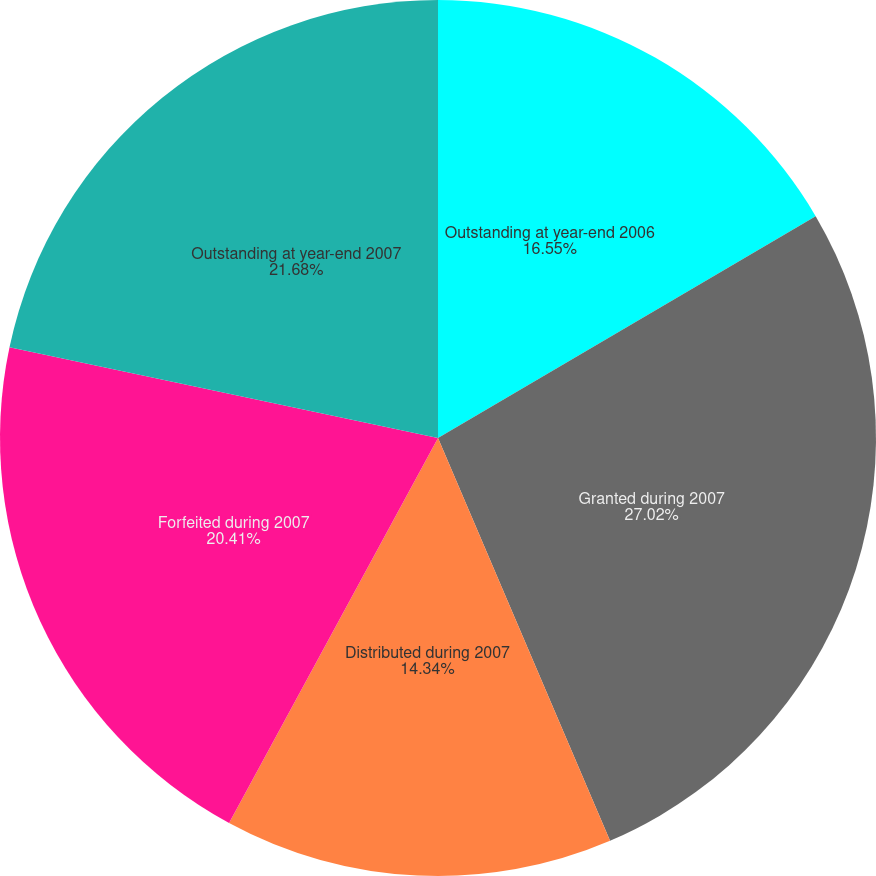Convert chart. <chart><loc_0><loc_0><loc_500><loc_500><pie_chart><fcel>Outstanding at year-end 2006<fcel>Granted during 2007<fcel>Distributed during 2007<fcel>Forfeited during 2007<fcel>Outstanding at year-end 2007<nl><fcel>16.55%<fcel>27.03%<fcel>14.34%<fcel>20.41%<fcel>21.68%<nl></chart> 